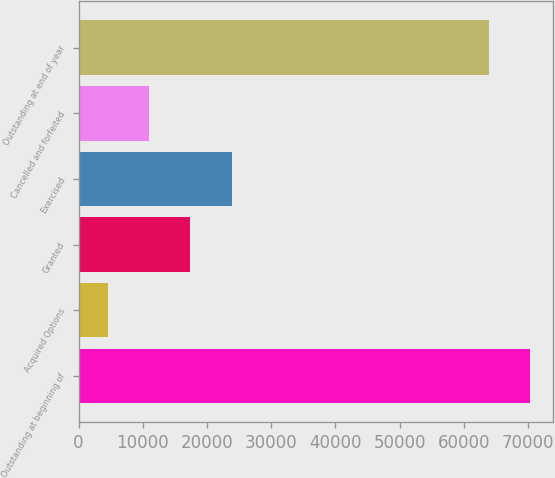Convert chart. <chart><loc_0><loc_0><loc_500><loc_500><bar_chart><fcel>Outstanding at beginning of<fcel>Acquired Options<fcel>Granted<fcel>Exercised<fcel>Cancelled and forfeited<fcel>Outstanding at end of year<nl><fcel>70382.6<fcel>4557<fcel>17430.2<fcel>23866.8<fcel>10993.6<fcel>63946<nl></chart> 